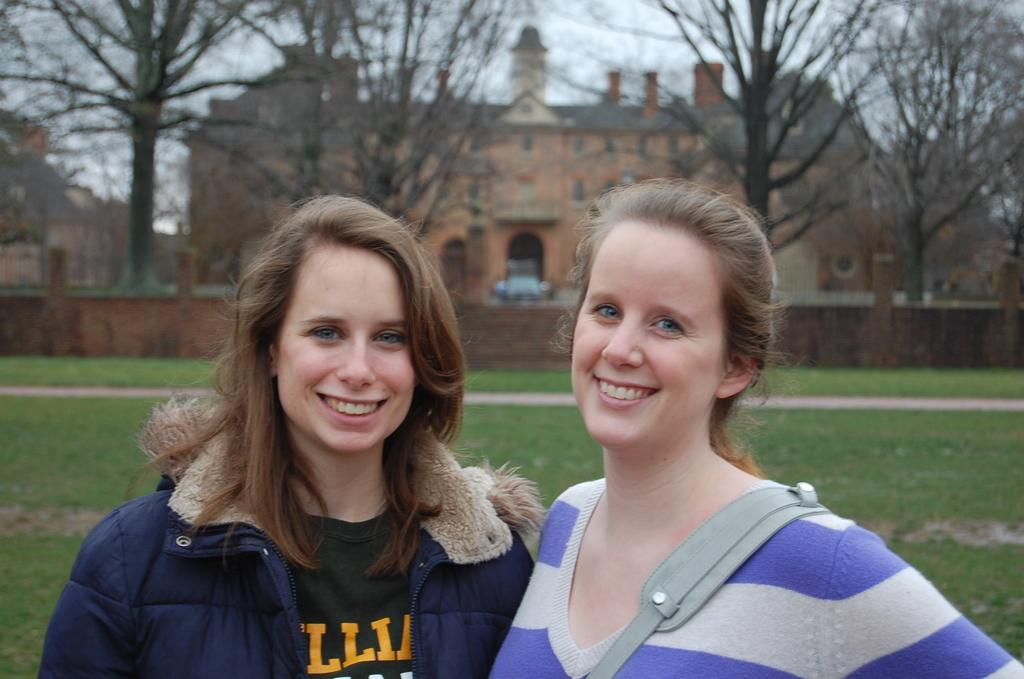How many women are in the image? There are two women in the image. What are the women doing in the image? The women are standing in the front, smiling, and giving a pose. What can be seen in the background of the image? There is a green lawn, a brown color castle house, and dry trees in the background. What type of air can be seen bursting out of the castle house in the image? There is no air or bursting effect visible in the image, and the castle house is not depicted as having any such feature. 